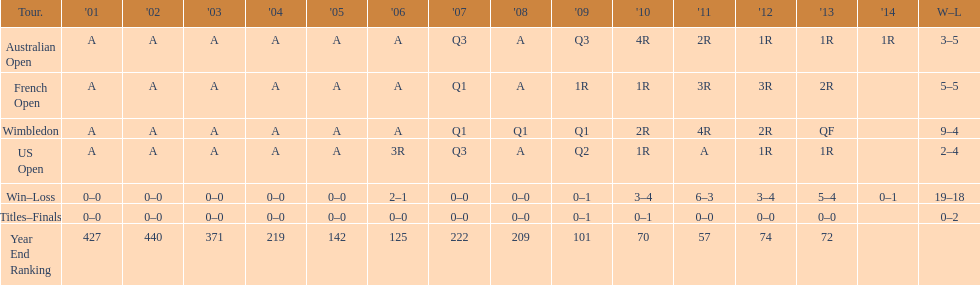In how many competitions were there 5 total defeats? 2. 